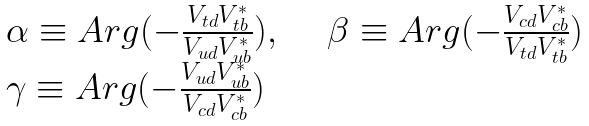<formula> <loc_0><loc_0><loc_500><loc_500>\begin{array} { l l } \alpha \equiv A r g ( - \frac { V _ { t d } V _ { t b } ^ { \ast } } { V _ { u d } V _ { u b } ^ { \ast } } ) , & \quad \beta \equiv A r g ( - \frac { V _ { c d } V _ { c b } ^ { \ast } } { V _ { t d } V _ { t b } ^ { \ast } } ) \\ \gamma \equiv A r g ( - \frac { V _ { u d } V _ { u b } ^ { \ast } } { V _ { c d } V _ { c b } ^ { \ast } } ) & \end{array}</formula> 